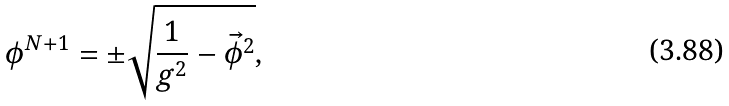<formula> <loc_0><loc_0><loc_500><loc_500>\phi ^ { N + 1 } = \pm \sqrt { \frac { 1 } { g ^ { 2 } } - { \vec { \phi } } ^ { 2 } } ,</formula> 